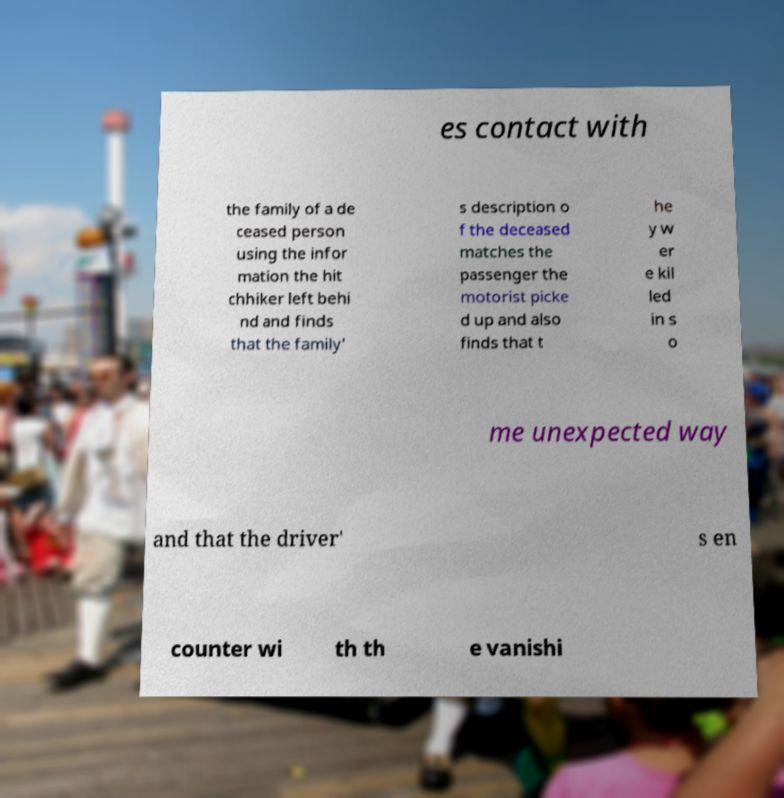What messages or text are displayed in this image? I need them in a readable, typed format. es contact with the family of a de ceased person using the infor mation the hit chhiker left behi nd and finds that the family' s description o f the deceased matches the passenger the motorist picke d up and also finds that t he y w er e kil led in s o me unexpected way and that the driver' s en counter wi th th e vanishi 